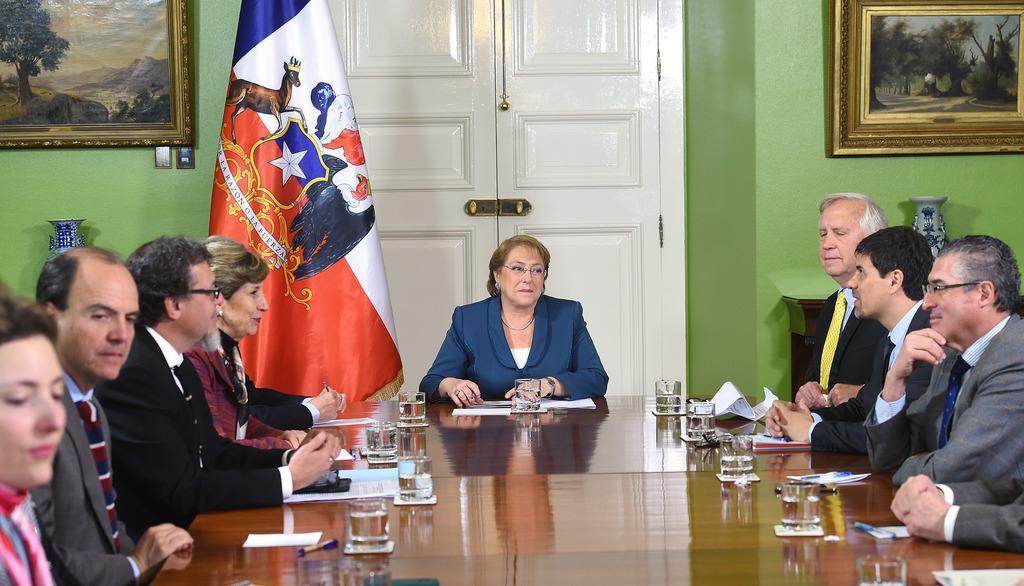Describe this image in one or two sentences. On the background we can see door, wall and photo frames over a wall. here we can see few persons sitting on the chairs in front of a table and on the table we can see water glasses, papers, pen. This is a flag. 